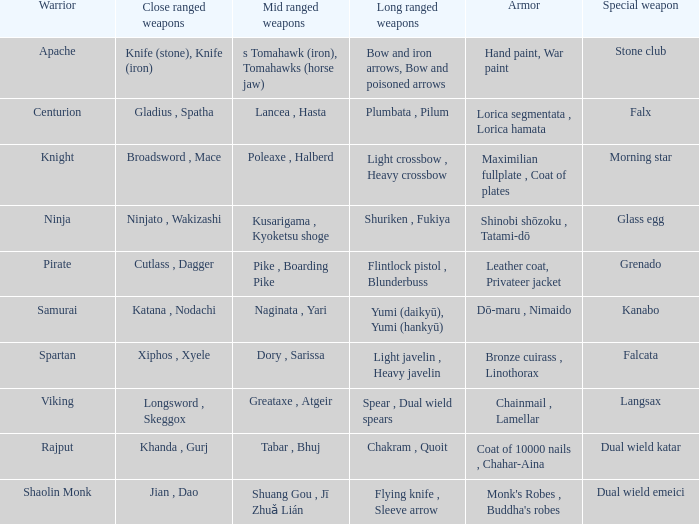If the exceptional weapon is glass egg, what is the close-combat weapon? Ninjato , Wakizashi. 